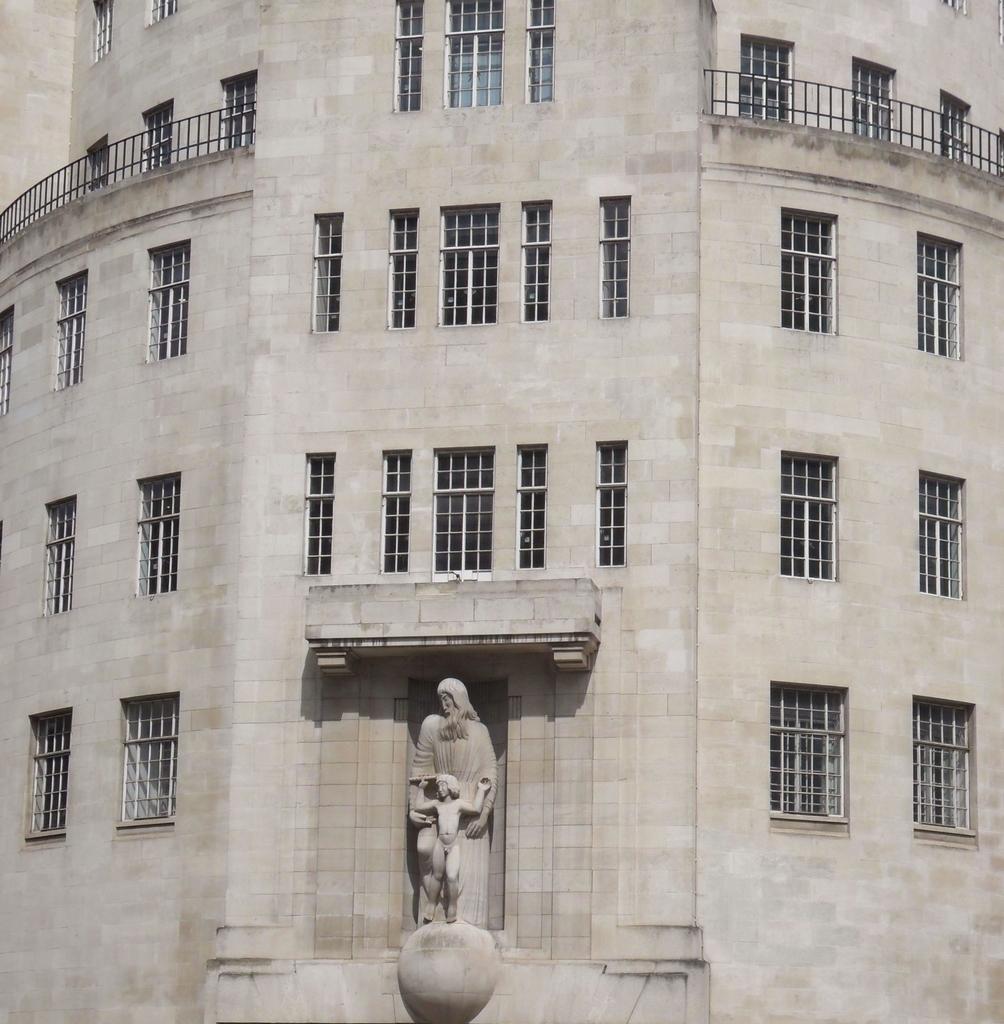Describe this image in one or two sentences. In this image I can see the statue to the building. I can also see many windows and railing to the building and this is in ash color. 